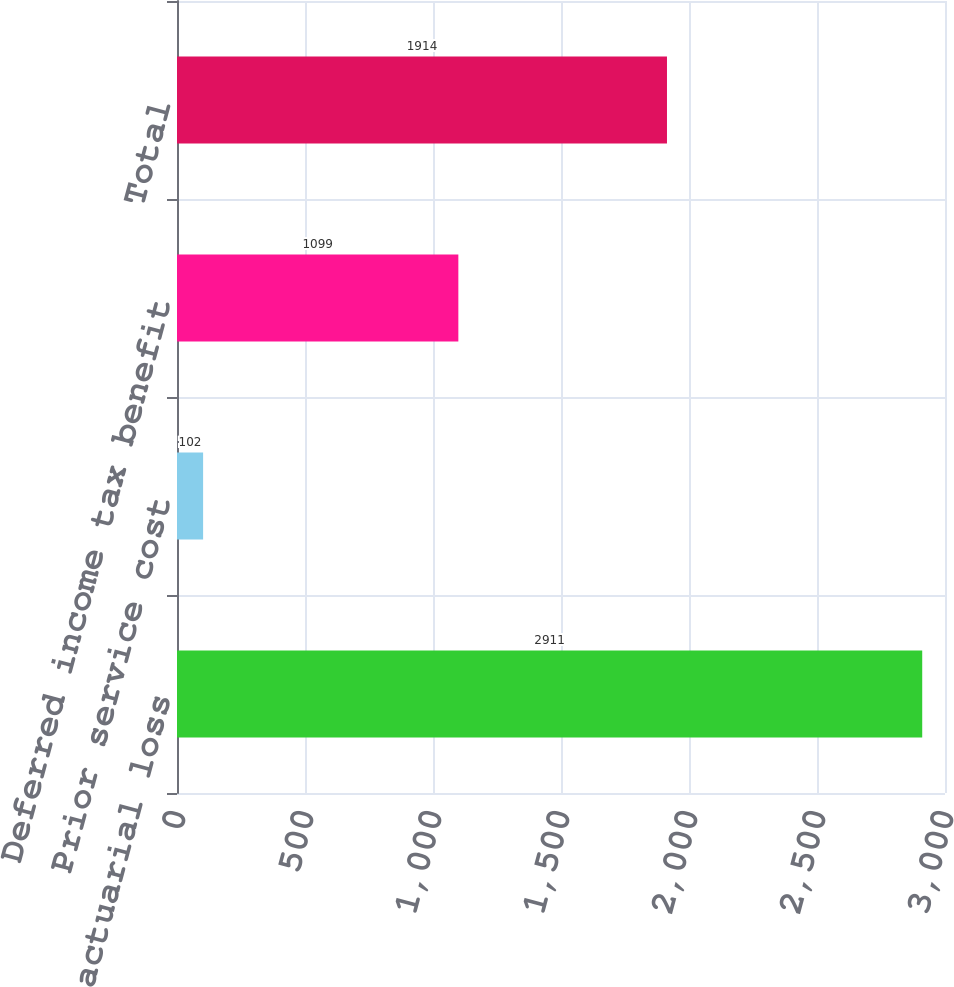<chart> <loc_0><loc_0><loc_500><loc_500><bar_chart><fcel>Net actuarial loss<fcel>Prior service cost<fcel>Deferred income tax benefit<fcel>Total<nl><fcel>2911<fcel>102<fcel>1099<fcel>1914<nl></chart> 